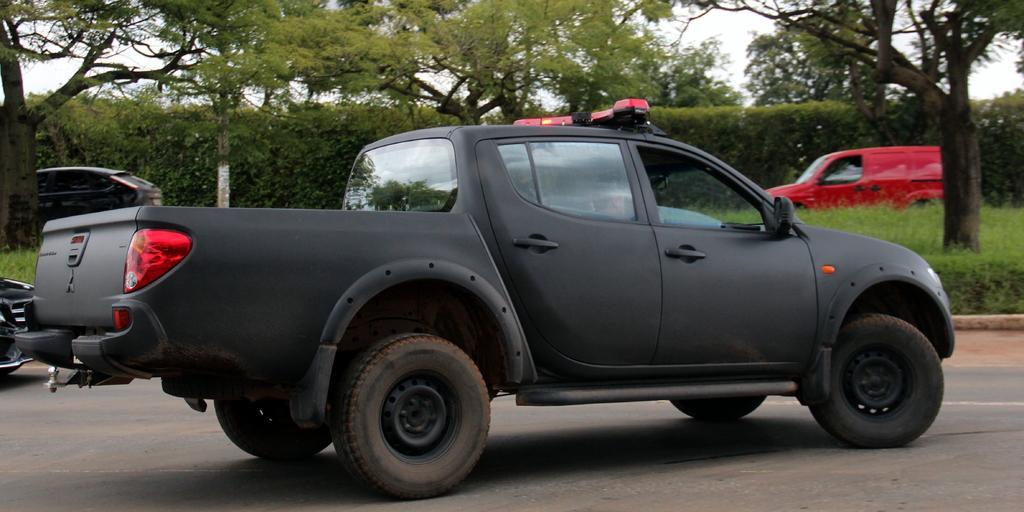In one or two sentences, can you explain what this image depicts? In this image we can see some vehicles on the road. On the backside we can see some trees, grass, some cars, a group of plants and the sky which looks cloudy. 